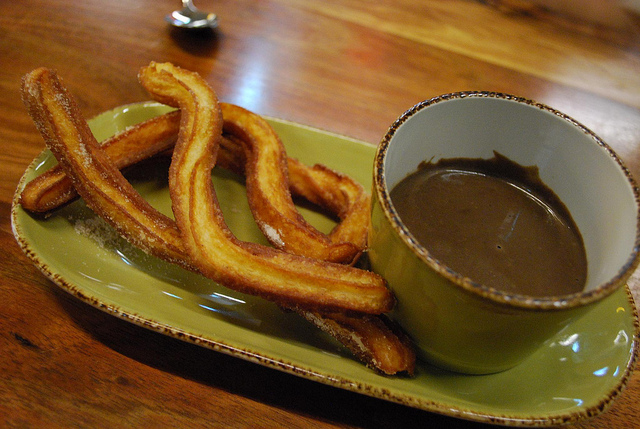What is the plate sitting on? The plate is sitting on a wooden table, which adds to the rustic aesthetic of the presentation. 